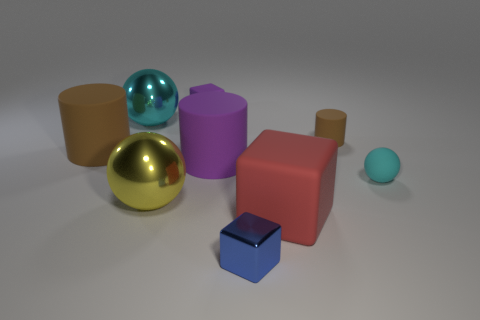Add 6 purple objects. How many purple objects exist? 8 Subtract all cyan spheres. How many spheres are left? 1 Subtract all small cubes. How many cubes are left? 1 Subtract 1 red cubes. How many objects are left? 8 Subtract all yellow balls. Subtract all yellow cylinders. How many balls are left? 2 Subtract all cyan spheres. How many purple blocks are left? 1 Subtract all big metal spheres. Subtract all cyan balls. How many objects are left? 5 Add 8 tiny purple things. How many tiny purple things are left? 9 